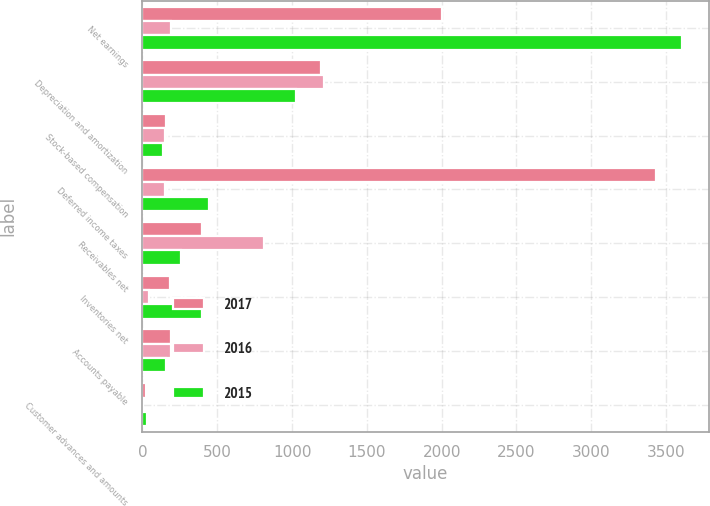<chart> <loc_0><loc_0><loc_500><loc_500><stacked_bar_chart><ecel><fcel>Net earnings<fcel>Depreciation and amortization<fcel>Stock-based compensation<fcel>Deferred income taxes<fcel>Receivables net<fcel>Inventories net<fcel>Accounts payable<fcel>Customer advances and amounts<nl><fcel>2017<fcel>2002<fcel>1195<fcel>158<fcel>3432<fcel>401<fcel>183<fcel>189<fcel>24<nl><fcel>2016<fcel>189<fcel>1215<fcel>149<fcel>152<fcel>811<fcel>46<fcel>188<fcel>3<nl><fcel>2015<fcel>3605<fcel>1026<fcel>138<fcel>445<fcel>256<fcel>398<fcel>160<fcel>32<nl></chart> 